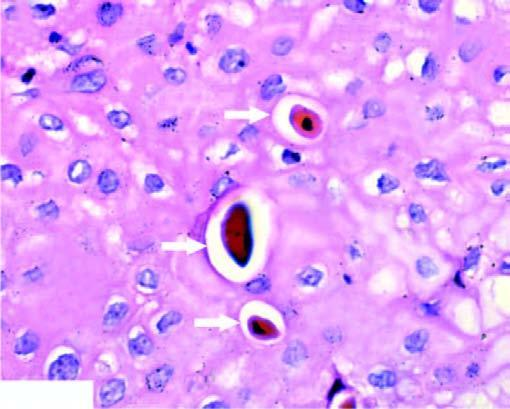s the dead cell seen in singles?
Answer the question using a single word or phrase. Yes 